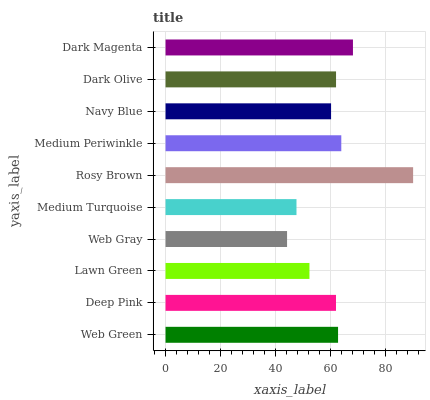Is Web Gray the minimum?
Answer yes or no. Yes. Is Rosy Brown the maximum?
Answer yes or no. Yes. Is Deep Pink the minimum?
Answer yes or no. No. Is Deep Pink the maximum?
Answer yes or no. No. Is Web Green greater than Deep Pink?
Answer yes or no. Yes. Is Deep Pink less than Web Green?
Answer yes or no. Yes. Is Deep Pink greater than Web Green?
Answer yes or no. No. Is Web Green less than Deep Pink?
Answer yes or no. No. Is Dark Olive the high median?
Answer yes or no. Yes. Is Deep Pink the low median?
Answer yes or no. Yes. Is Web Gray the high median?
Answer yes or no. No. Is Dark Olive the low median?
Answer yes or no. No. 